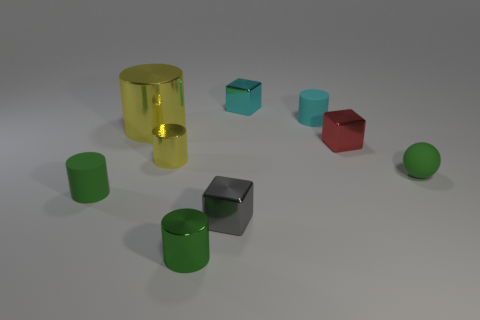What is the shape of the tiny rubber thing that is the same color as the small rubber ball?
Offer a terse response. Cylinder. Are there more tiny rubber cylinders than big shiny things?
Offer a very short reply. Yes. What color is the small rubber cylinder that is behind the green object on the right side of the tiny metallic thing that is on the right side of the cyan cube?
Make the answer very short. Cyan. Is the shape of the cyan thing to the left of the cyan rubber cylinder the same as  the gray shiny object?
Keep it short and to the point. Yes. The matte ball that is the same size as the gray metallic block is what color?
Your answer should be compact. Green. How many tiny green rubber objects are there?
Your answer should be very brief. 2. Is the material of the cube behind the small red metallic cube the same as the sphere?
Provide a succinct answer. No. The thing that is both behind the tiny red shiny cube and left of the small gray thing is made of what material?
Keep it short and to the point. Metal. There is a metallic cylinder that is the same color as the big metallic thing; what size is it?
Make the answer very short. Small. The gray cube in front of the green rubber object that is to the right of the green rubber cylinder is made of what material?
Your response must be concise. Metal. 